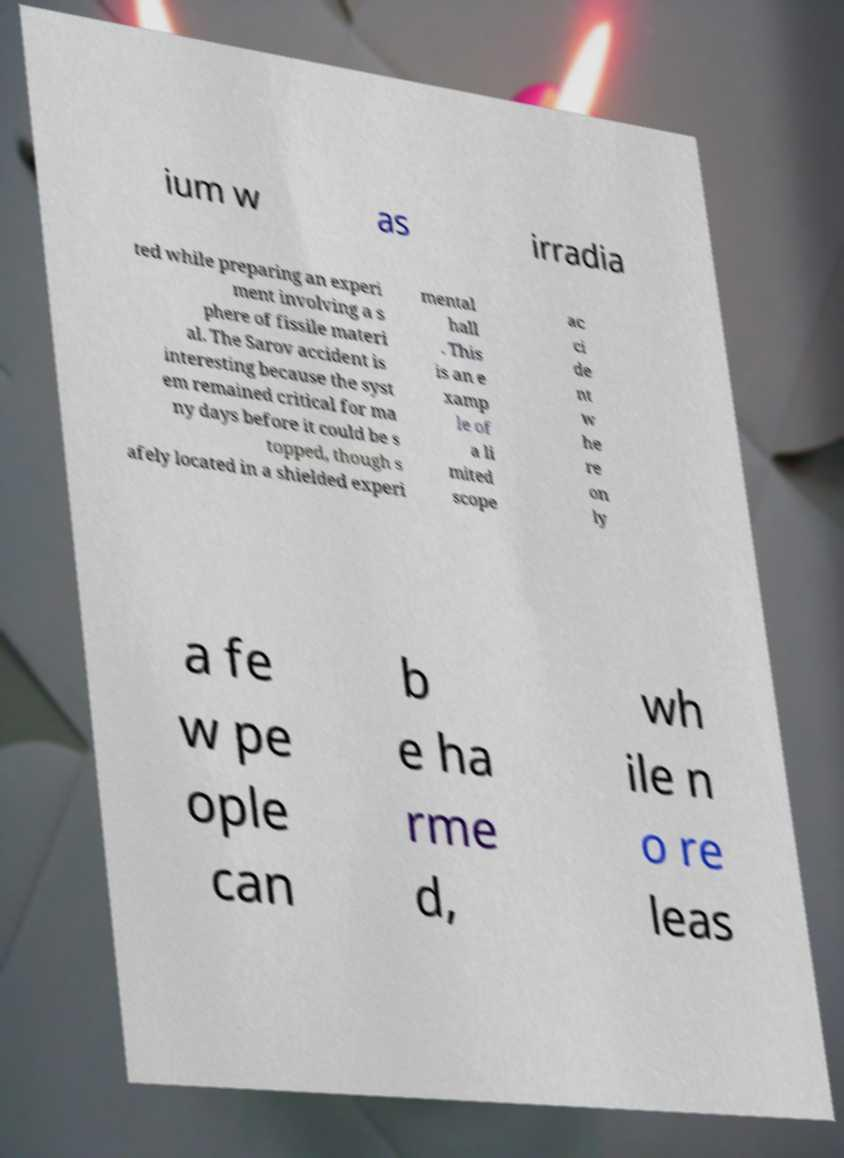Please read and relay the text visible in this image. What does it say? ium w as irradia ted while preparing an experi ment involving a s phere of fissile materi al. The Sarov accident is interesting because the syst em remained critical for ma ny days before it could be s topped, though s afely located in a shielded experi mental hall . This is an e xamp le of a li mited scope ac ci de nt w he re on ly a fe w pe ople can b e ha rme d, wh ile n o re leas 